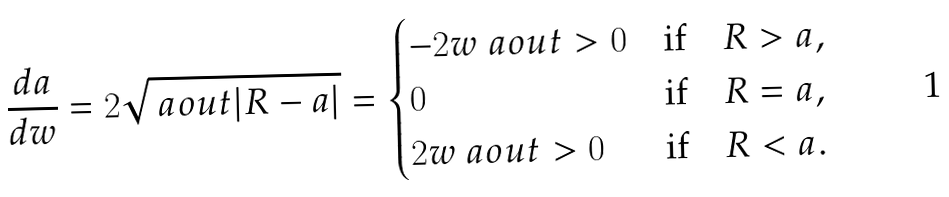<formula> <loc_0><loc_0><loc_500><loc_500>\frac { d a } { d w } = 2 \sqrt { \ a o u t | R - a | } = \begin{cases} - 2 w \ a o u t > 0 & \text {if} \quad R > a , \\ 0 & \text {if} \quad R = a , \\ 2 w \ a o u t > 0 & \text {if} \quad R < a . \end{cases}</formula> 